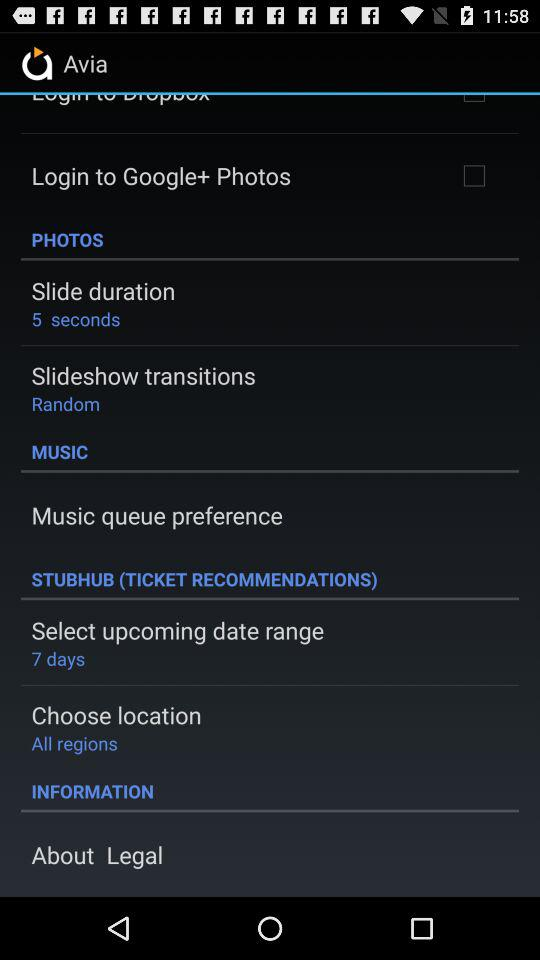What is the status of "Login to Google+ Photos"? The status of "Login to Google+ Photos" is "off". 